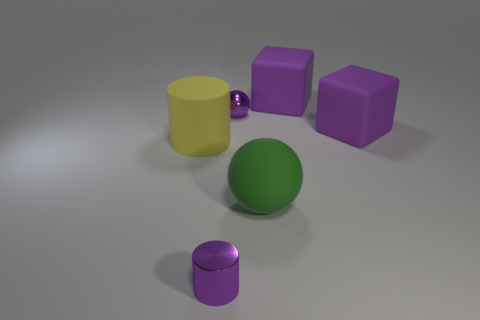Are there more tiny objects behind the yellow rubber object than big objects?
Offer a terse response. No. Is there any other thing that has the same material as the large yellow object?
Give a very brief answer. Yes. What is the shape of the metal object that is the same color as the tiny metal sphere?
Keep it short and to the point. Cylinder. What number of balls are either small metallic things or green objects?
Provide a succinct answer. 2. The metal thing on the right side of the cylinder in front of the yellow thing is what color?
Ensure brevity in your answer.  Purple. Is the color of the rubber ball the same as the big matte block in front of the purple ball?
Your answer should be compact. No. The thing that is made of the same material as the small purple sphere is what size?
Offer a very short reply. Small. There is a metal sphere that is the same color as the small cylinder; what size is it?
Make the answer very short. Small. Do the tiny cylinder and the rubber cylinder have the same color?
Your answer should be compact. No. There is a purple cube behind the purple metallic object that is behind the small metal cylinder; are there any purple cylinders right of it?
Your response must be concise. No. 